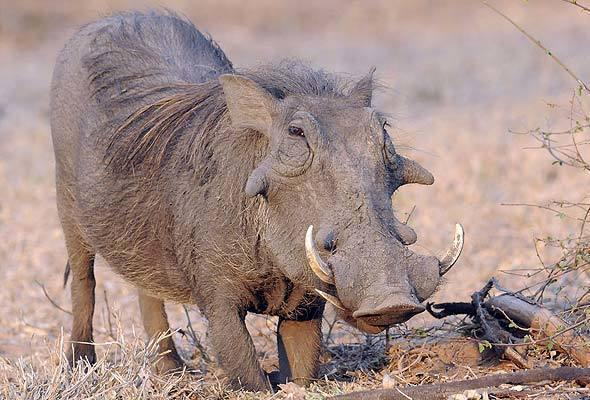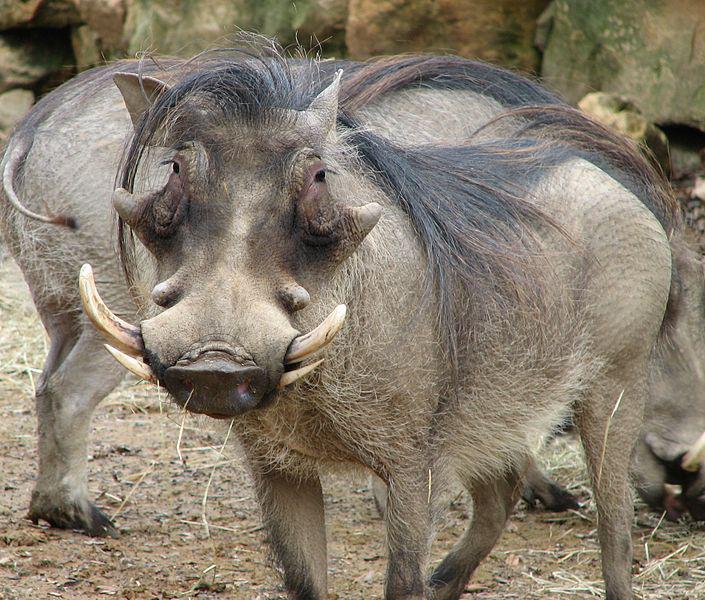The first image is the image on the left, the second image is the image on the right. Analyze the images presented: Is the assertion "We see a baby warthog in one of the images." valid? Answer yes or no. No. The first image is the image on the left, the second image is the image on the right. For the images shown, is this caption "One image contains more than one warthog." true? Answer yes or no. Yes. 